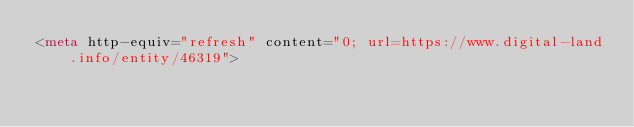Convert code to text. <code><loc_0><loc_0><loc_500><loc_500><_HTML_><meta http-equiv="refresh" content="0; url=https://www.digital-land.info/entity/46319"></code> 